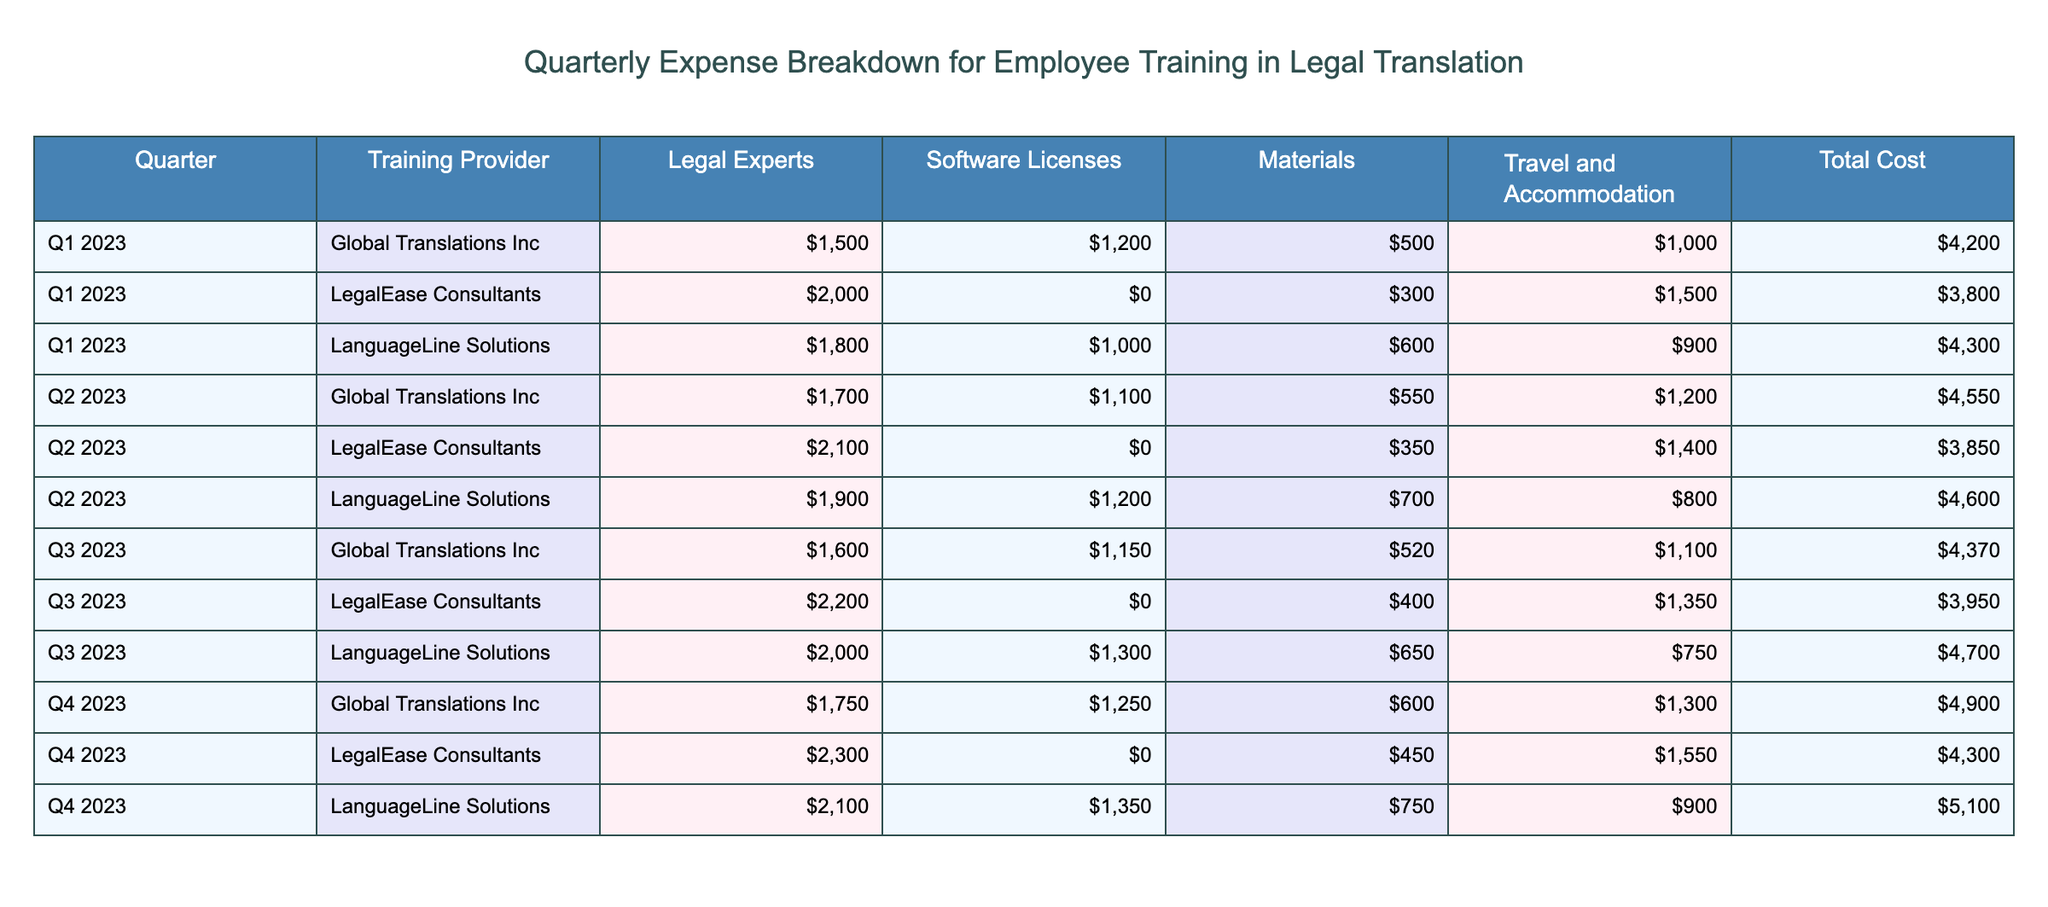What is the total cost for Q1 2023 from Global Translations Inc? From the table, we can find the row corresponding to Q1 2023 and Global Translations Inc. The Total Cost for that entry is $4,200.
Answer: $4,200 Which training provider had the highest total cost in Q3 2023? In Q3 2023, by looking at the Total Cost for each training provider, Global Translations Inc cost $4,370, LegalEase Consultants cost $3,950, and LanguageLine Solutions cost $4,700. The highest total cost is from LanguageLine Solutions.
Answer: LanguageLine Solutions What is the average total cost across all quarters for LegalEase Consultants? To find the average for LegalEase Consultants, we sum the Total Costs: $3,800 (Q1) + $3,850 (Q2) + $3,950 (Q3) + $4,300 (Q4) = $15,900. There are 4 quarters, so the average is $15,900 divided by 4, which equals $3,975.
Answer: $3,975 Did the costs for Software Licenses ever hit $0 for any provider in 2023? By checking the Software Licenses column for all rows, LegalEase Consultants has $0 in the table for Q1, Q2, Q3, and Q4. Therefore, it is true that the costs for Software Licenses hit $0.
Answer: Yes What is the difference in total cost between Q4 2023 and Q1 2023 for LanguageLine Solutions? The Total Cost for LanguageLine Solutions in Q4 2023 is $5,100, and in Q1 2023 it is $4,300. The difference is $5,100 minus $4,300, which equals $800.
Answer: $800 Which quarter had the lowest total cost across all training providers? By examining the Total Costs for all quarters, Q3 2023 has the lowest sum (Global Translations Inc $4,370, LegalEase Consultants $3,950, LanguageLine Solutions $4,700), totaling $13,020, which is the lowest compared to other quarters.
Answer: Q3 2023 What is the total travel and accommodation cost for all quarters combined? The total for Travel and Accommodation can be calculated by adding each entry: $1,000 (Q1 2023, Global) + $1,500 (Q1 2023, LegalEase) + $900 (Q1 2023, LanguageLine) + $1,200 (Q2 2023, Global) + $1,400 (Q2 2023, LegalEase) + $800 (Q2 2023, LanguageLine) + $1,100 (Q3 2023, Global) + $1,350 (Q3 2023, LegalEase) + $750 (Q3 2023, LanguageLine) + $1,300 (Q4 2023, Global) + $1,550 (Q4 2023, LegalEase) + $900 (Q4 2023, LanguageLine) = $13,350.
Answer: $13,350 Is the average cost for training providers increasing each quarter? To determine if the average is increasing, we compute the average for each quarter: Q1 (Total costs are $4,200 + $3,800 + $4,300 = $12,300, average is $4,100), Q2 (Total costs are $4,550 + $3,850 + $4,600 = $13,000, average is $4,333), Q3 (Total costs are $4,370 + $3,950 + $4,700 = $13,020, average is $4,340), Q4 (Total costs are $4,900 + $4,300 + $5,100 = $14,300, average is $4,767). The average increases from Q1 to Q4, thus the statement is true.
Answer: Yes 